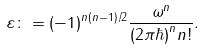<formula> <loc_0><loc_0><loc_500><loc_500>\varepsilon \colon = ( - 1 ) ^ { n ( n - 1 ) / 2 } \frac { \omega ^ { n } } { ( 2 \pi \hbar { ) } ^ { n } n ! } .</formula> 